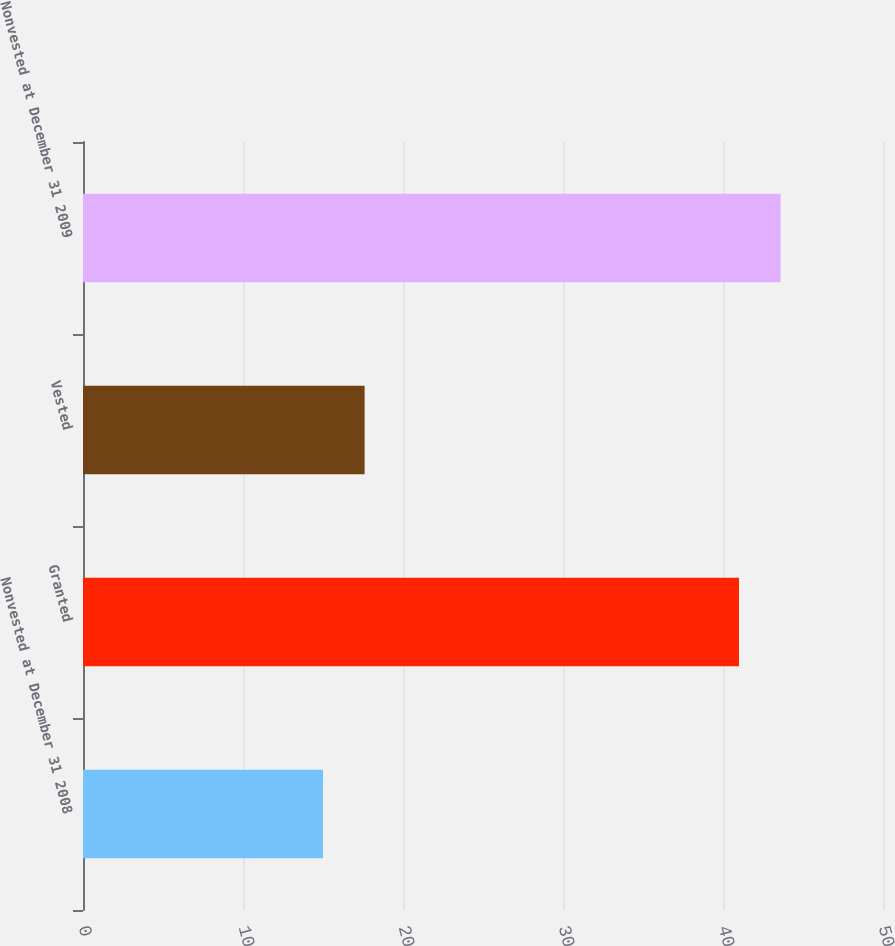Convert chart. <chart><loc_0><loc_0><loc_500><loc_500><bar_chart><fcel>Nonvested at December 31 2008<fcel>Granted<fcel>Vested<fcel>Nonvested at December 31 2009<nl><fcel>15<fcel>41<fcel>17.6<fcel>43.6<nl></chart> 